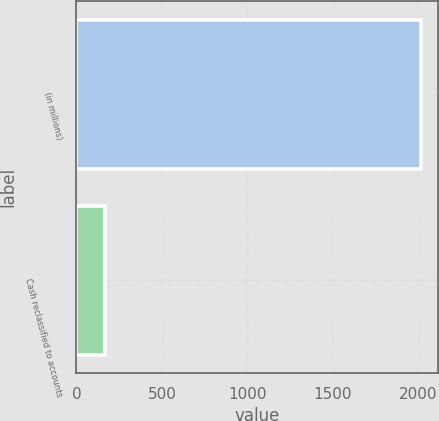Convert chart. <chart><loc_0><loc_0><loc_500><loc_500><bar_chart><fcel>(in millions)<fcel>Cash reclassified to accounts<nl><fcel>2013<fcel>168<nl></chart> 